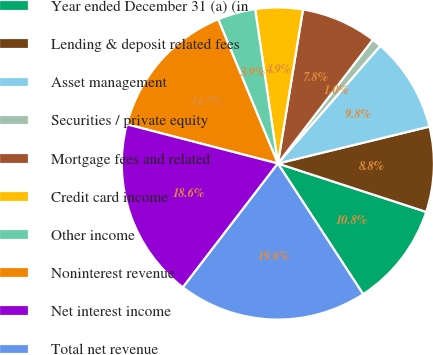<chart> <loc_0><loc_0><loc_500><loc_500><pie_chart><fcel>Year ended December 31 (a) (in<fcel>Lending & deposit related fees<fcel>Asset management<fcel>Securities / private equity<fcel>Mortgage fees and related<fcel>Credit card income<fcel>Other income<fcel>Noninterest revenue<fcel>Net interest income<fcel>Total net revenue<nl><fcel>10.78%<fcel>8.82%<fcel>9.8%<fcel>0.98%<fcel>7.84%<fcel>4.9%<fcel>3.92%<fcel>14.71%<fcel>18.63%<fcel>19.61%<nl></chart> 